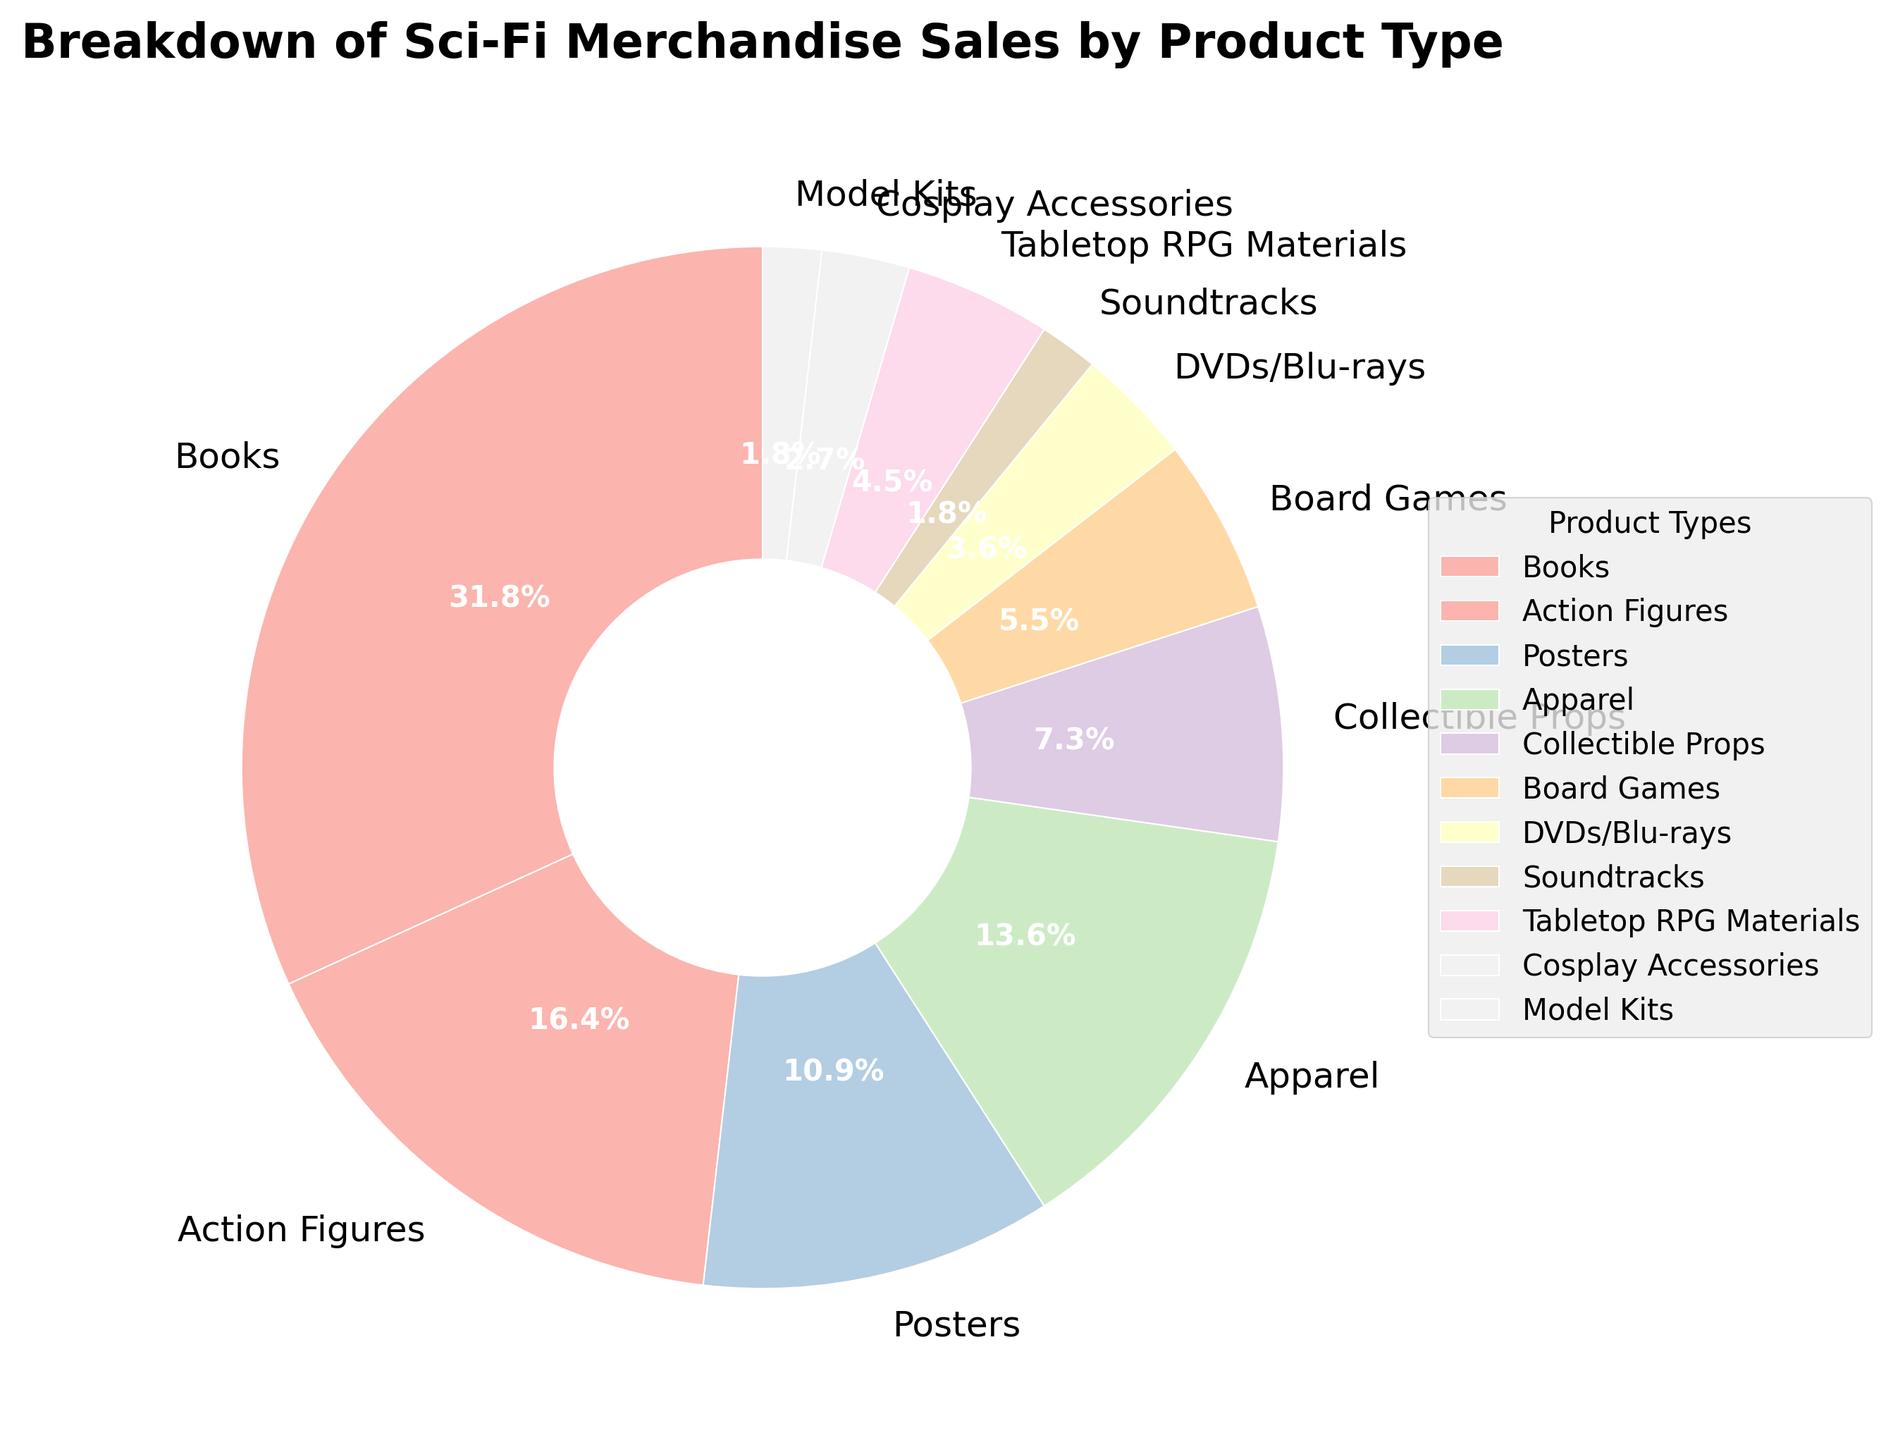Which product type has the highest percentage of sales? Find the slice of the pie chart that is the largest. The largest slice represents Books with 35% sales.
Answer: Books How much more percentage of sales do Books have compared to Apparel? Books have 35% and Apparel has 15%. Subtracting the two, 35% - 15% = 20%. So, Books have 20% more sales compared to Apparel.
Answer: 20% Which product type has the smallest percentage of sales? Identify the smallest slice in the pie chart, which represents the least sales. This is the Model Kits with 2% sales.
Answer: Model Kits What is the combined percentage of sales for Action Figures, Posters, and Apparel? Sum the percentages of Action Figures (18%), Posters (12%), and Apparel (15%). 18% + 12% + 15% = 45%.
Answer: 45% Is the percentage of sales for Collectible Props greater than that for Tabletop RPG Materials? Compare the two percentages. Collectible Props have 8% and Tabletop RPG Materials have 5%, so yes, 8% is greater than 5%.
Answer: Yes Among Posters, Cosplay Accessories, and Soundtracks, which product type has the highest percentage of sales? Compare the percentages of Posters (12%), Cosplay Accessories (3%), and Soundtracks (2%). Posters have the highest percentage at 12%.
Answer: Posters Which is greater, the combined sales of DVDs/Blu-rays and Soundtracks or Model Kits and Cosplay Accessories? Find the sum of DVDs/Blu-rays (4%) + Soundtracks (2%) = 6% and the sum of Model Kits (2%) + Cosplay Accessories (3%) = 5%. So, 6% is greater than 5%.
Answer: DVDs/Blu-rays and Soundtracks How many product types have sales percentages of less than 10%? Identify all the product types with percentages under 10%. They are Collectible Props (8%), Board Games (6%), DVDs/Blu-rays (4%), Soundtracks (2%), Tabletop RPG Materials (5%), Cosplay Accessories (3%), and Model Kits (2%). There are 7 such product types.
Answer: 7 By how much percent is the sales of Board Games more than DVDs/Blu-rays? Board Games have 6% and DVDs/Blu-rays have 4%. Subtracting the two, 6% - 4% = 2%. So, Board Games have 2% more sales than DVDs/Blu-rays.
Answer: 2% If you combine the sales percentage of lower-performing products (those with less than 5%), what is the total? Identify the lower-performing products: DVDs/Blu-rays (4%), Soundtracks (2%), Tabletop RPG Materials (5%), Cosplay Accessories (3%), and Model Kits (2%). Their total sales are 4% + 2% + 5% + 3% + 2% = 16%.
Answer: 16% 